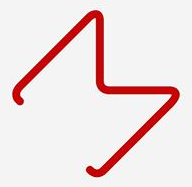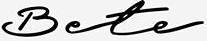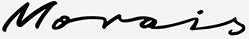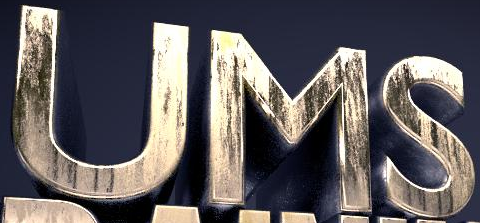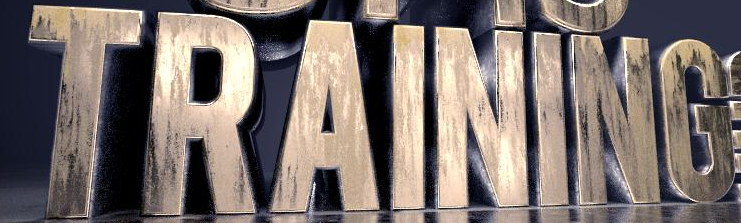What words can you see in these images in sequence, separated by a semicolon? M; Bete; Morois; UMS; TRAINING 